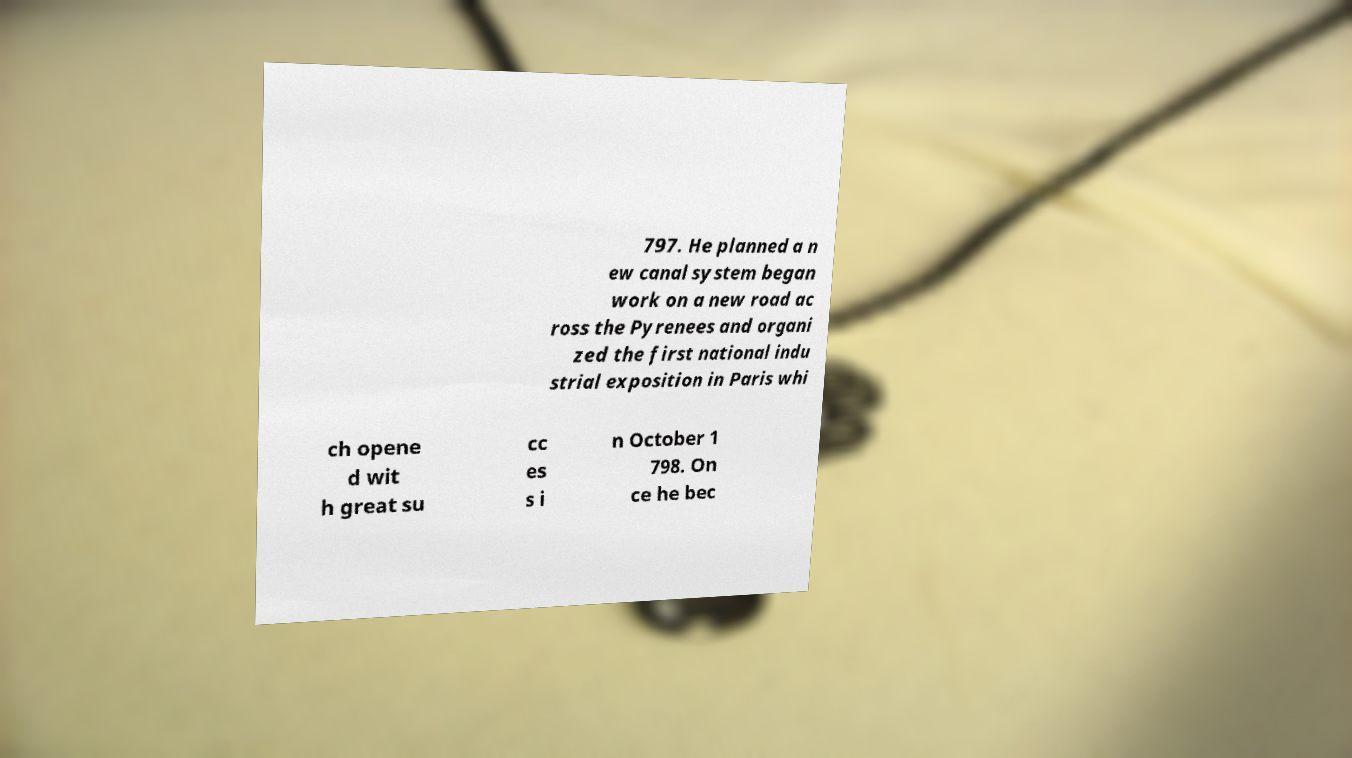For documentation purposes, I need the text within this image transcribed. Could you provide that? 797. He planned a n ew canal system began work on a new road ac ross the Pyrenees and organi zed the first national indu strial exposition in Paris whi ch opene d wit h great su cc es s i n October 1 798. On ce he bec 